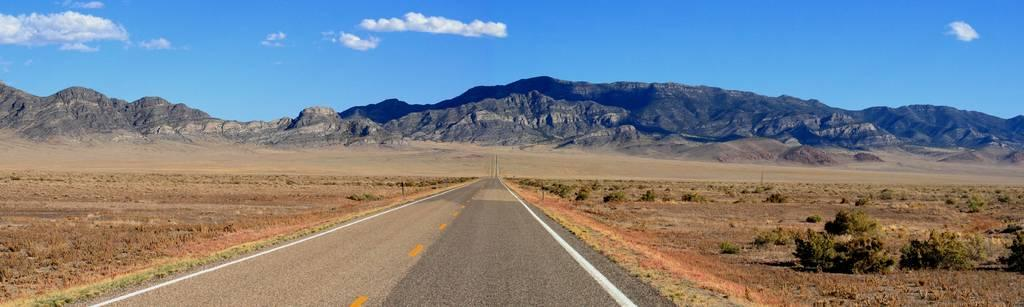What can be seen in the sky in the image? The sky with clouds is visible in the image. What type of terrain is present in the image? There are hills in the image. What is the ground like in the image? The ground is visible in the image. What type of vegetation is present in the image? Grass and shrubs are present in the image. What man-made feature can be seen in the image? There is a road in the image. What degree of difficulty is indicated by the map in the image? There is no map present in the image, so it is not possible to determine the degree of difficulty. 